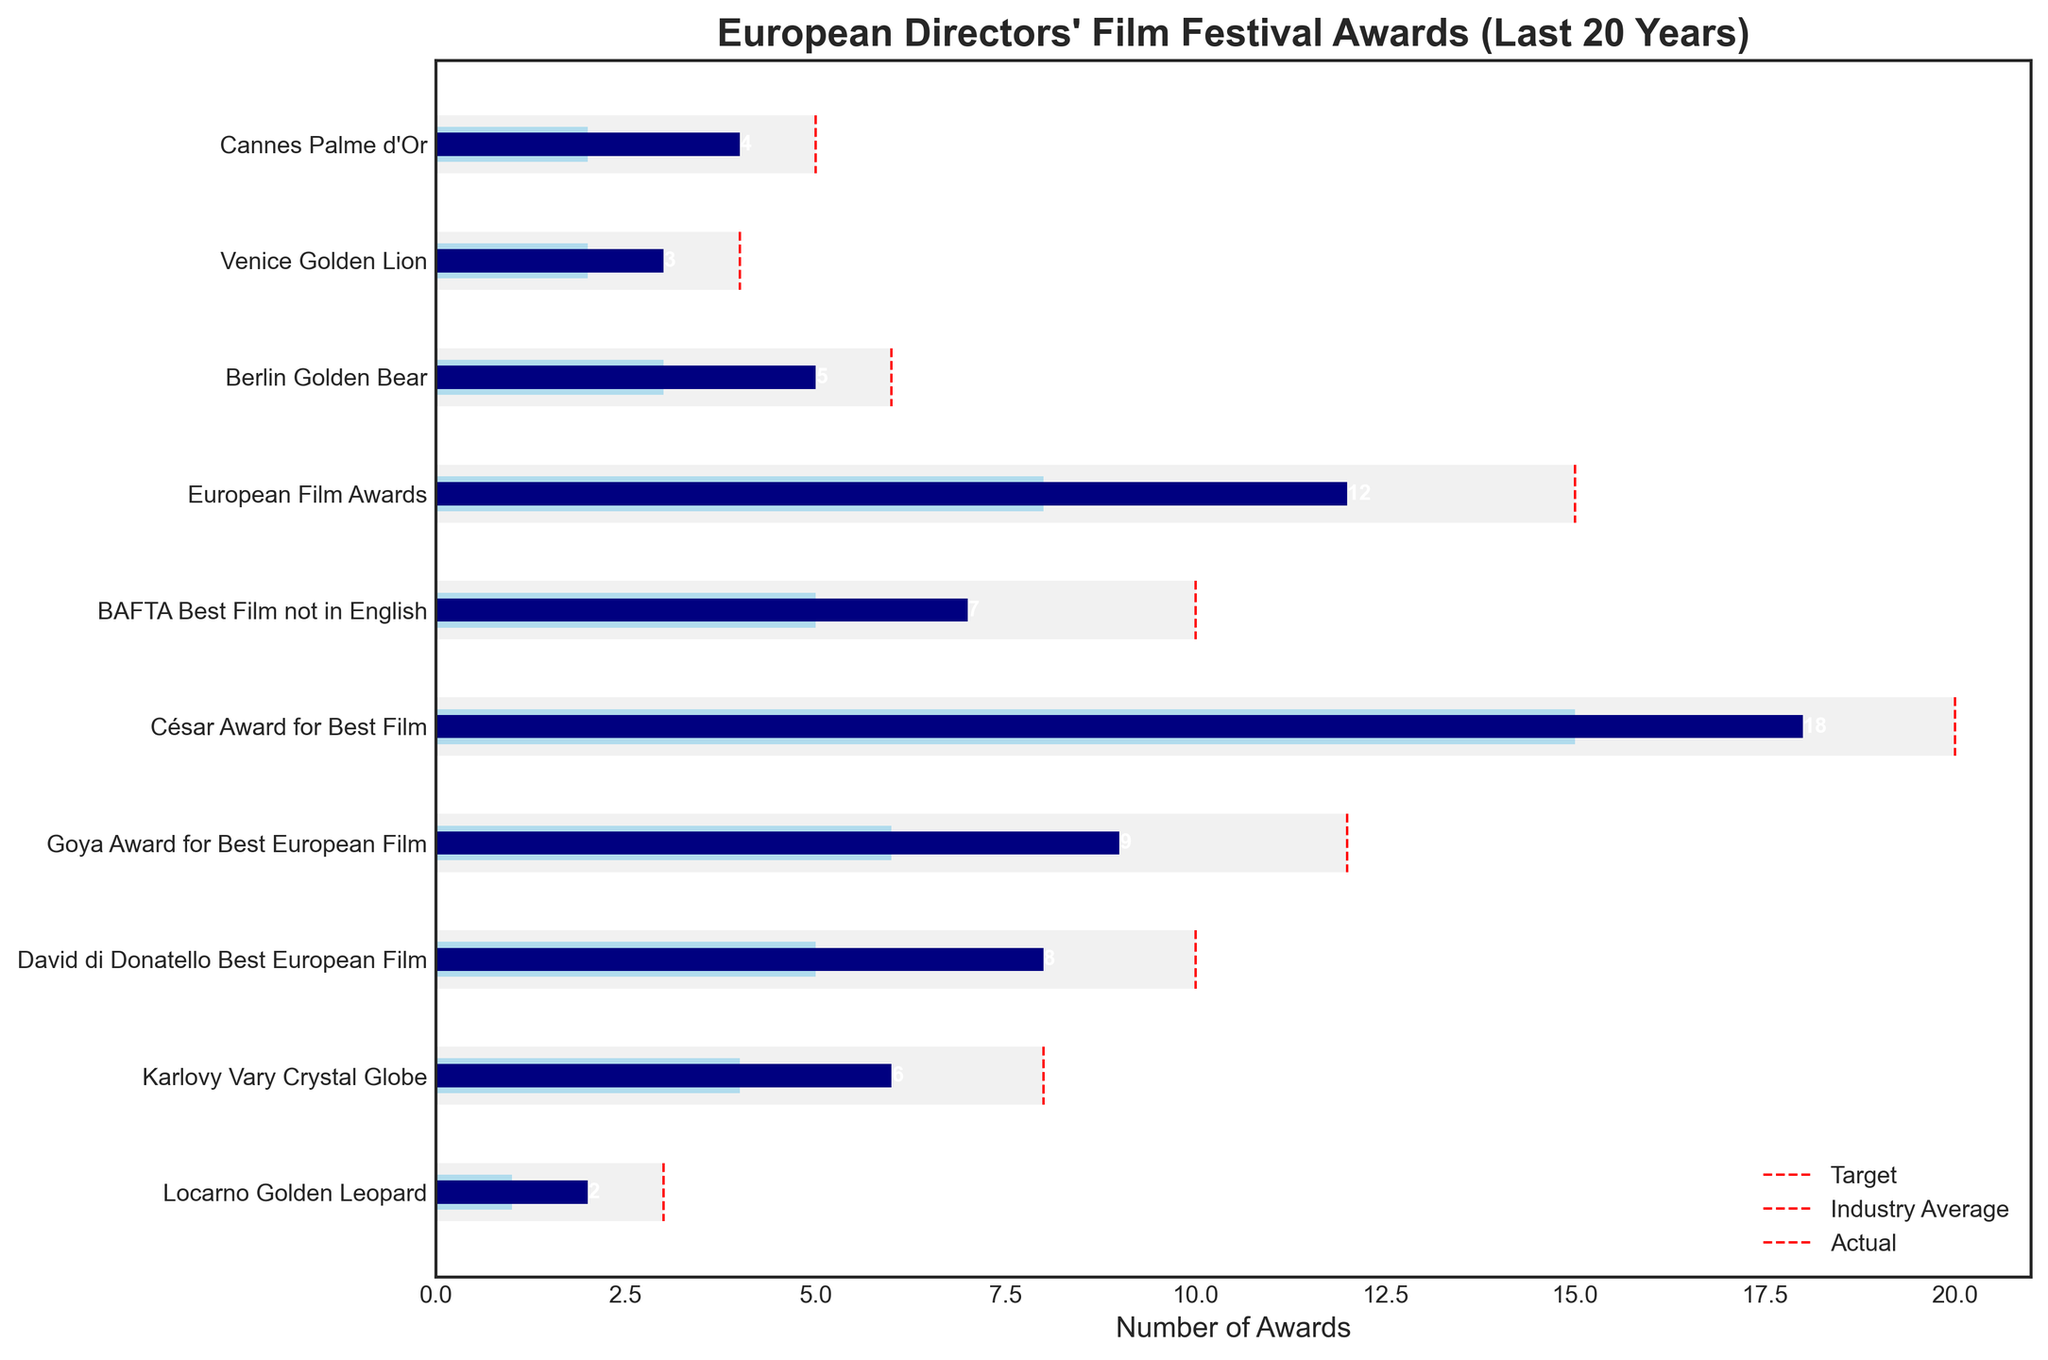What is the title of the chart? The title is displayed at the top of the chart. It is usually a brief description of what the chart represents.
Answer: European Directors' Film Festival Awards (Last 20 Years) How many categories are compared in the chart? Count the total number of different categories listed on the y-axis.
Answer: 10 Which category has the highest number of actual awards? Look at the lengths of the blue bars representing the actual awards and find the longest one.
Answer: César Award for Best Film How does the actual number of Cannes Palme d'Or awards compare with the industry average? Compare the lengths of the blue and light blue bars for the Cannes Palme d'Or category.
Answer: The actual number (4) is greater than the industry average (2) What is the target number of awards for Berlin Golden Bear? Find the red vertical dashed line for Berlin Golden Bear and note the value where it meets the x-axis.
Answer: 6 Which category has the smallest difference between actual and target awards? Calculate the differences between the actual and target awards for each category, identify the smallest difference.
Answer: Locarno Golden Leopard What is the total number of actual awards across all categories? Sum the values of the actual awards for all categories: 4 + 3 + 5 + 12 + 7 + 18 + 9 + 8 + 6 + 2 = 74
Answer: 74 How does the European Film Awards' number of actual awards compare with the expected target? Compare the blue bar (actual) with the red dashed line (target) for European Film Awards.
Answer: The actual number (12) is less than the target (15) Which category has the largest gap between actual and industry average? Calculate the differences between actual and industry average values for each category, find the largest gap.
Answer: European Film Awards What is the median number of actual awards for all categories? Order the actual awards values and find the middle number: [2, 3, 4, 5, 6, 7, 8, 9, 12, 18]. The middle numbers are 6 and 7, so the median is (6+7)/2 = 6.5
Answer: 6.5 